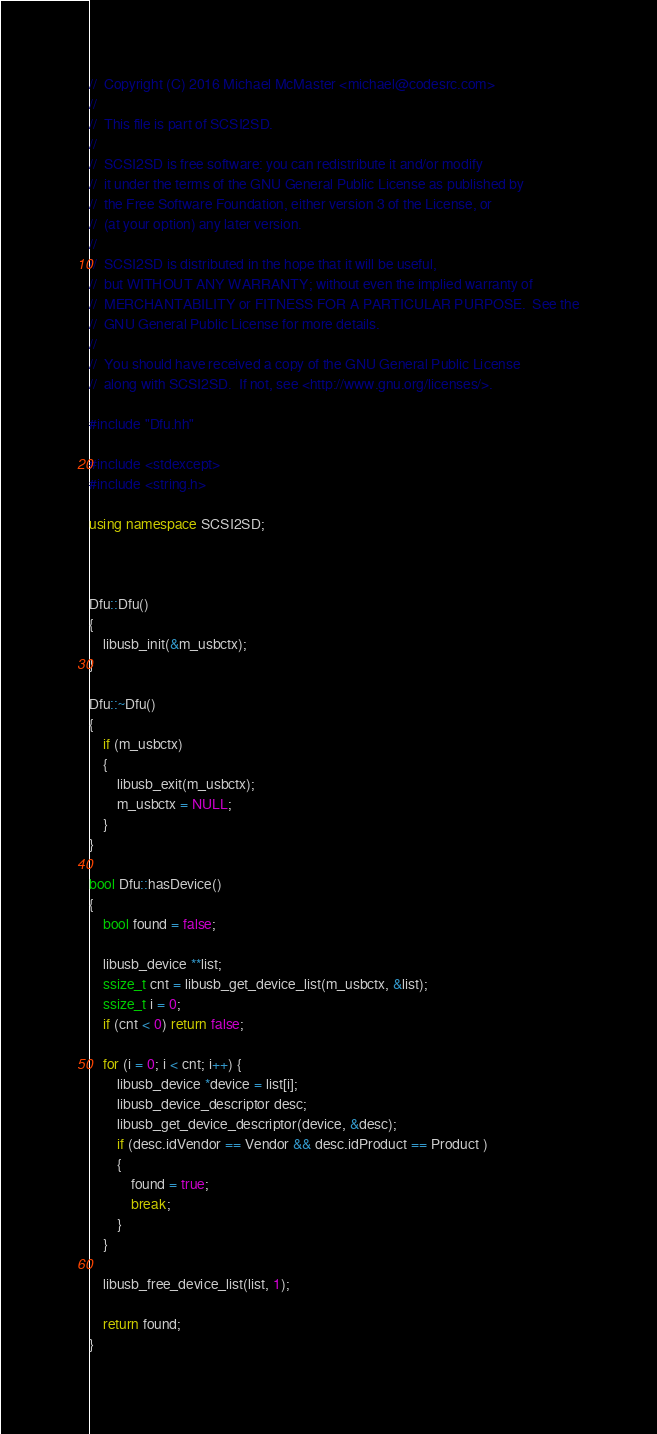Convert code to text. <code><loc_0><loc_0><loc_500><loc_500><_C++_>//	Copyright (C) 2016 Michael McMaster <michael@codesrc.com>
//
//	This file is part of SCSI2SD.
//
//	SCSI2SD is free software: you can redistribute it and/or modify
//	it under the terms of the GNU General Public License as published by
//	the Free Software Foundation, either version 3 of the License, or
//	(at your option) any later version.
//
//	SCSI2SD is distributed in the hope that it will be useful,
//	but WITHOUT ANY WARRANTY; without even the implied warranty of
//	MERCHANTABILITY or FITNESS FOR A PARTICULAR PURPOSE.  See the
//	GNU General Public License for more details.
//
//	You should have received a copy of the GNU General Public License
//	along with SCSI2SD.  If not, see <http://www.gnu.org/licenses/>.

#include "Dfu.hh"

#include <stdexcept>
#include <string.h>

using namespace SCSI2SD;



Dfu::Dfu()
{
	libusb_init(&m_usbctx);
}

Dfu::~Dfu()
{
	if (m_usbctx)
	{
		libusb_exit(m_usbctx);
		m_usbctx = NULL;
	}
}

bool Dfu::hasDevice()
{
	bool found = false;

	libusb_device **list;
	ssize_t cnt = libusb_get_device_list(m_usbctx, &list);
	ssize_t i = 0;
	if (cnt < 0) return false;

	for (i = 0; i < cnt; i++) {
		libusb_device *device = list[i];
		libusb_device_descriptor desc;
		libusb_get_device_descriptor(device, &desc);
		if (desc.idVendor == Vendor && desc.idProduct == Product )
		{
			found = true;
			break;
		}
	}

	libusb_free_device_list(list, 1);

	return found;
}

</code> 